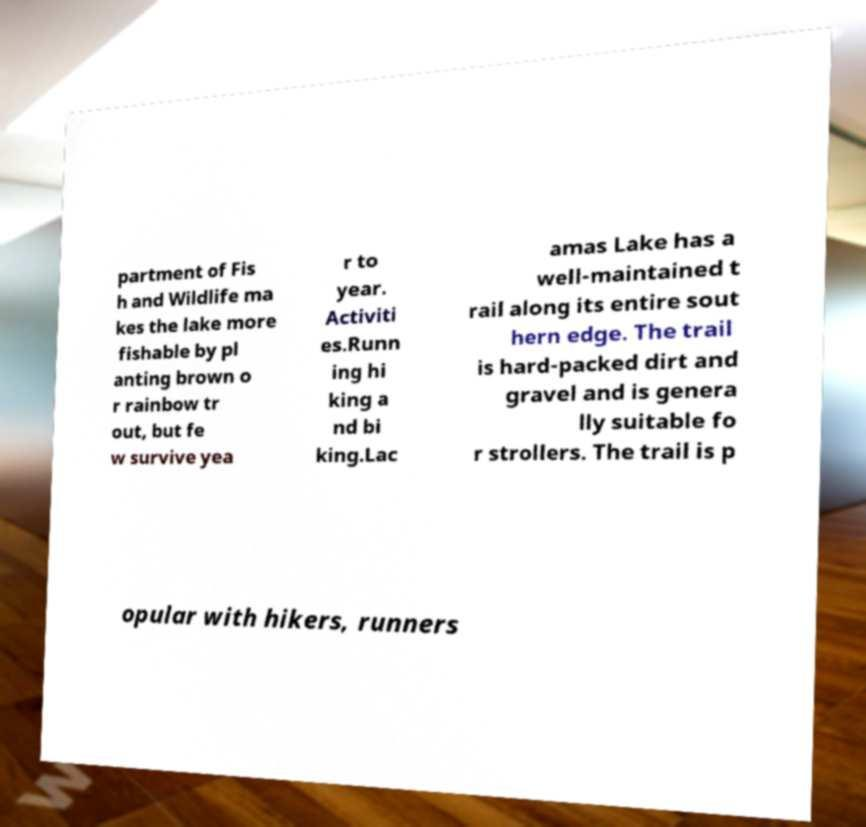There's text embedded in this image that I need extracted. Can you transcribe it verbatim? partment of Fis h and Wildlife ma kes the lake more fishable by pl anting brown o r rainbow tr out, but fe w survive yea r to year. Activiti es.Runn ing hi king a nd bi king.Lac amas Lake has a well-maintained t rail along its entire sout hern edge. The trail is hard-packed dirt and gravel and is genera lly suitable fo r strollers. The trail is p opular with hikers, runners 